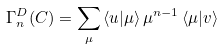<formula> <loc_0><loc_0><loc_500><loc_500>\Gamma _ { n } ^ { D } ( C ) = \sum _ { \mu } \, \langle { u } | \mu \rangle \, \mu ^ { n - 1 } \, \langle \mu | { v } \rangle</formula> 